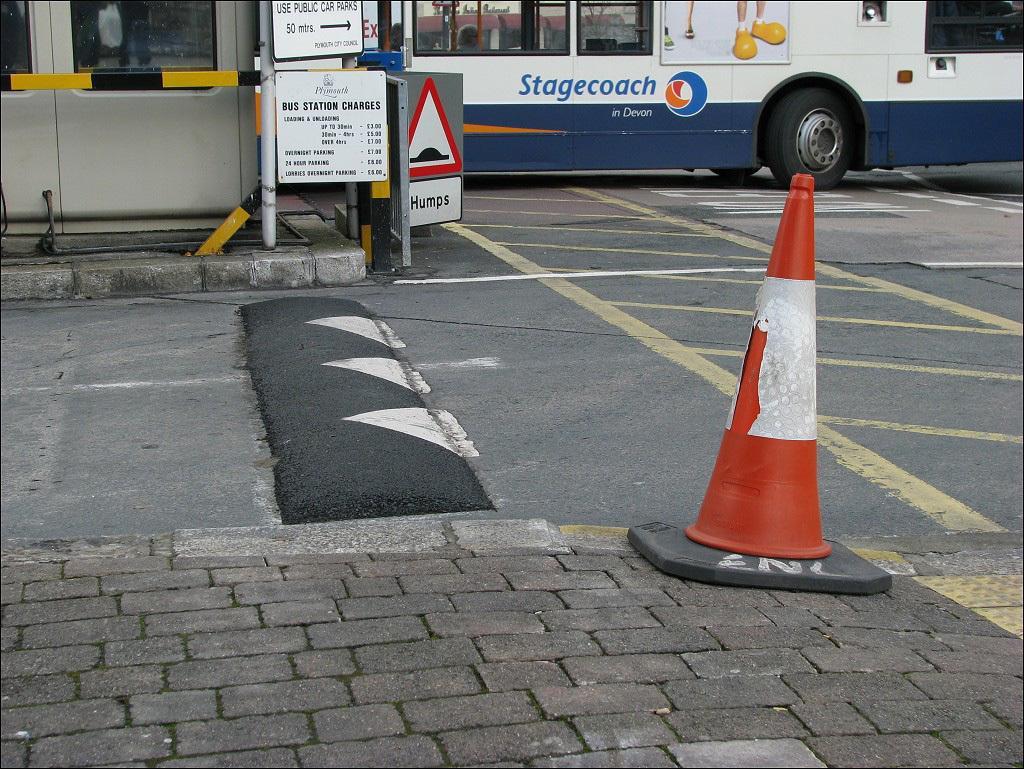Please provide a concise description of this image. In this image I can see a road in the centre and in the front I can see an orange colored traffic cone. In the background I can see few poles, few boards, a bus, few lines on the road and on these boards I can see something is written. 